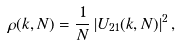Convert formula to latex. <formula><loc_0><loc_0><loc_500><loc_500>\rho ( k , N ) = \frac { 1 } { N } \left | U _ { 2 1 } ( k , N ) \right | ^ { 2 } ,</formula> 